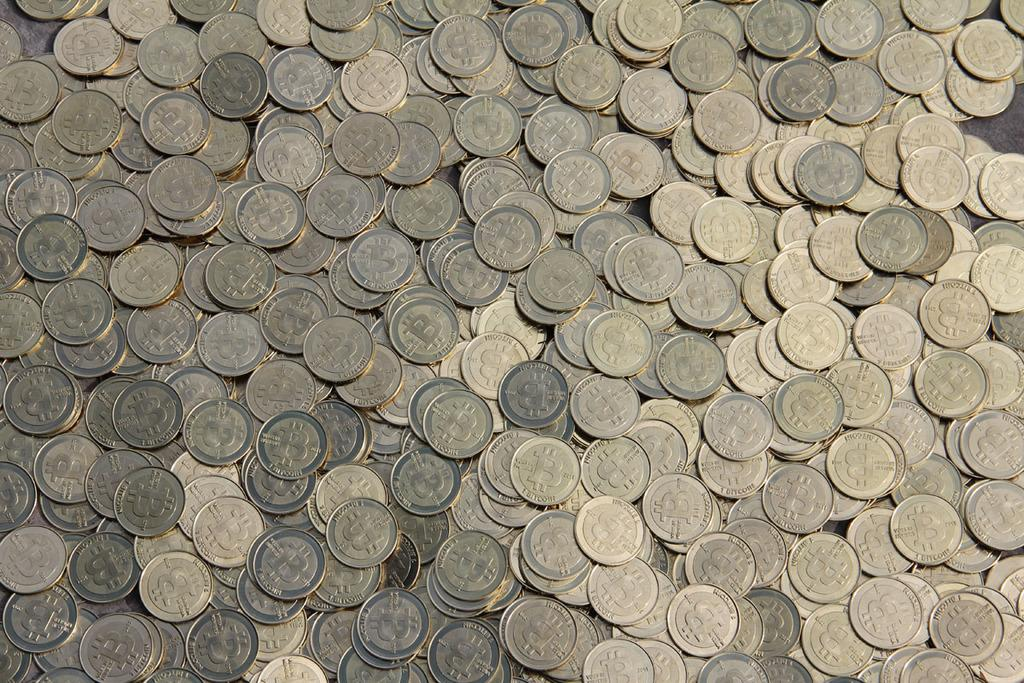What objects are present in the image? There are coins in the image. Can you describe the appearance of the coins? The coins appear to be round and metallic. What might be the purpose of the coins in the image? The coins may be used for transactions or as a form of currency. What type of alarm can be heard going off in the image? There is no alarm present in the image, as it only features coins. 